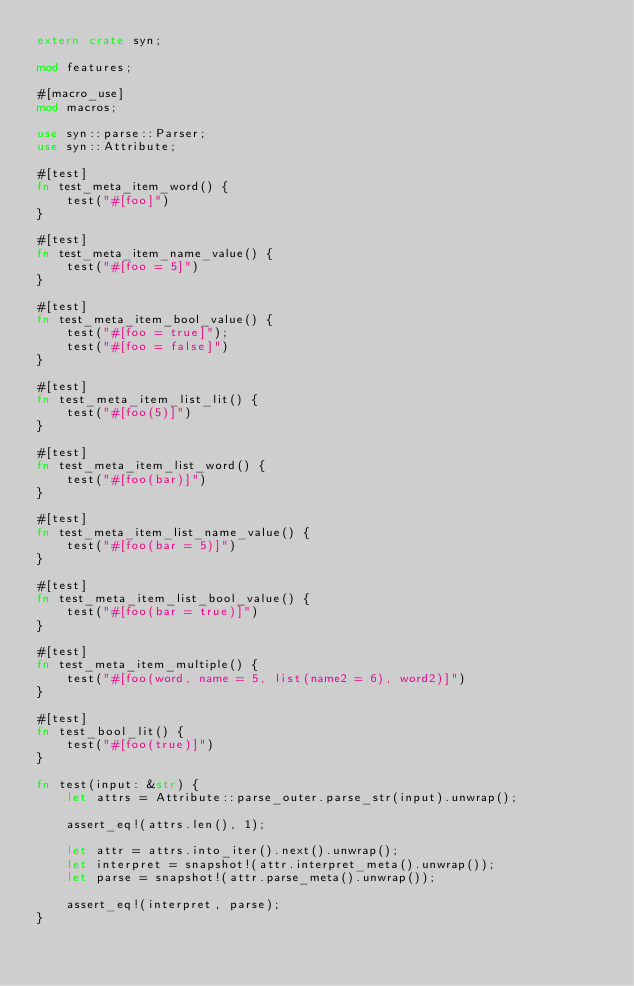Convert code to text. <code><loc_0><loc_0><loc_500><loc_500><_Rust_>extern crate syn;

mod features;

#[macro_use]
mod macros;

use syn::parse::Parser;
use syn::Attribute;

#[test]
fn test_meta_item_word() {
    test("#[foo]")
}

#[test]
fn test_meta_item_name_value() {
    test("#[foo = 5]")
}

#[test]
fn test_meta_item_bool_value() {
    test("#[foo = true]");
    test("#[foo = false]")
}

#[test]
fn test_meta_item_list_lit() {
    test("#[foo(5)]")
}

#[test]
fn test_meta_item_list_word() {
    test("#[foo(bar)]")
}

#[test]
fn test_meta_item_list_name_value() {
    test("#[foo(bar = 5)]")
}

#[test]
fn test_meta_item_list_bool_value() {
    test("#[foo(bar = true)]")
}

#[test]
fn test_meta_item_multiple() {
    test("#[foo(word, name = 5, list(name2 = 6), word2)]")
}

#[test]
fn test_bool_lit() {
    test("#[foo(true)]")
}

fn test(input: &str) {
    let attrs = Attribute::parse_outer.parse_str(input).unwrap();

    assert_eq!(attrs.len(), 1);

    let attr = attrs.into_iter().next().unwrap();
    let interpret = snapshot!(attr.interpret_meta().unwrap());
    let parse = snapshot!(attr.parse_meta().unwrap());

    assert_eq!(interpret, parse);
}
</code> 